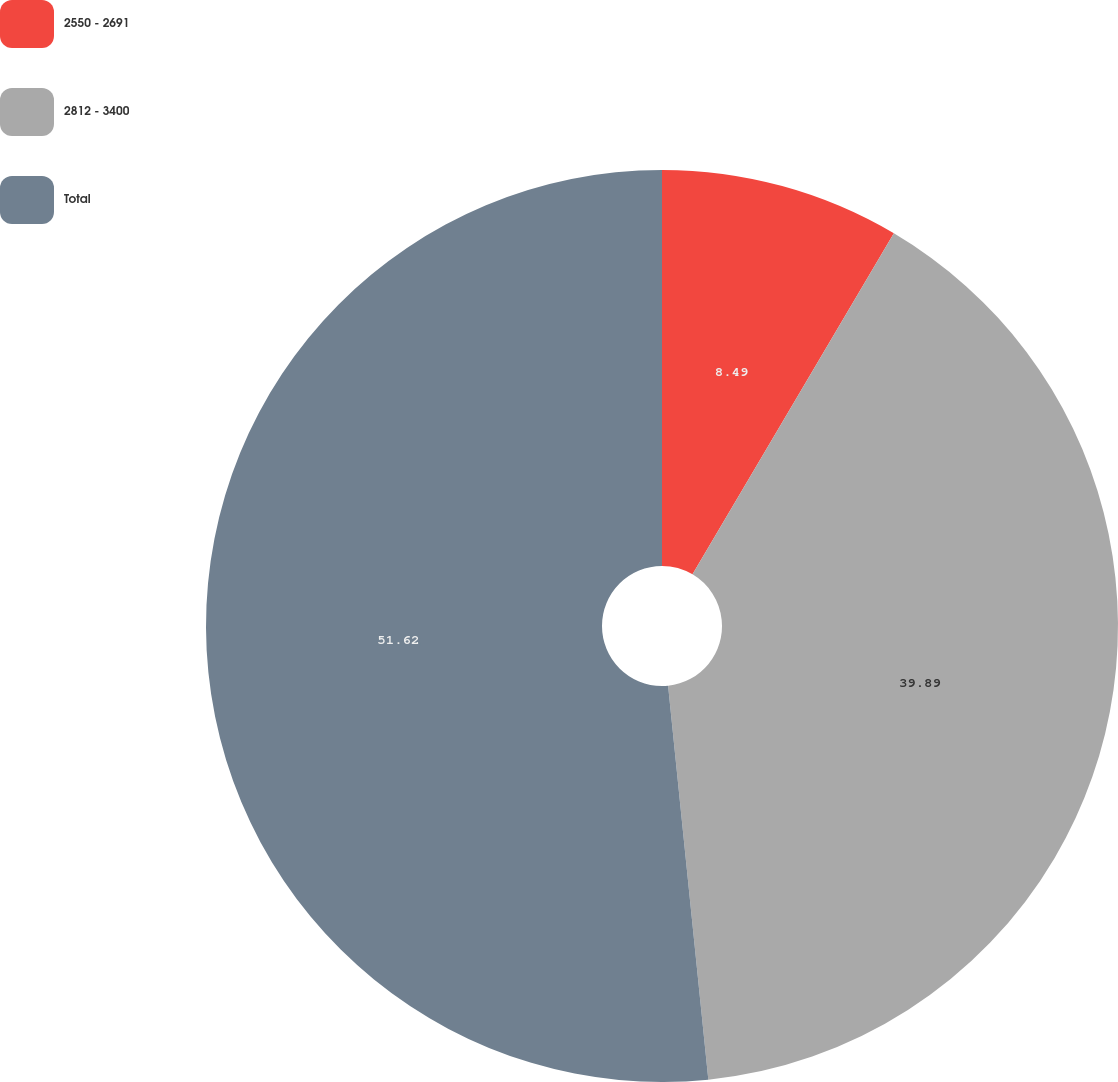<chart> <loc_0><loc_0><loc_500><loc_500><pie_chart><fcel>2550 - 2691<fcel>2812 - 3400<fcel>Total<nl><fcel>8.49%<fcel>39.89%<fcel>51.62%<nl></chart> 